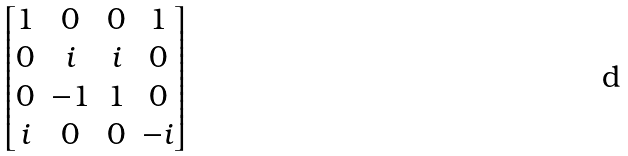<formula> <loc_0><loc_0><loc_500><loc_500>\begin{bmatrix} 1 & 0 & 0 & 1 \\ 0 & i & i & 0 \\ 0 & - 1 & 1 & 0 \\ i & 0 & 0 & - i \\ \end{bmatrix}</formula> 